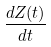<formula> <loc_0><loc_0><loc_500><loc_500>\frac { d Z ( t ) } { d t }</formula> 